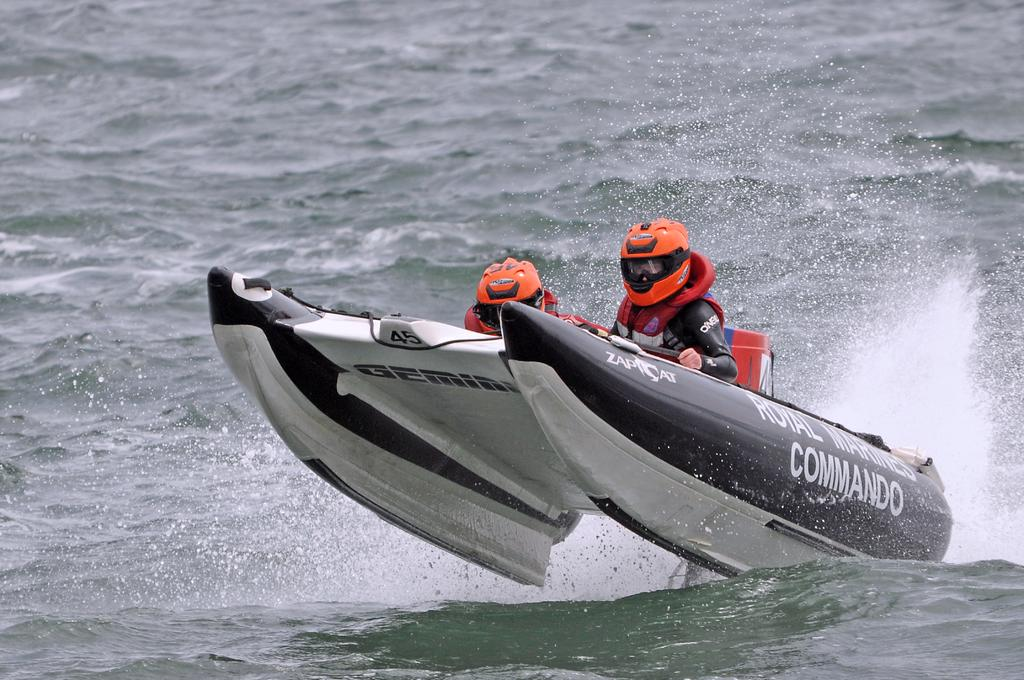<image>
Provide a brief description of the given image. A speedboat that says Royal Marine Commandos on the side catches some air. 